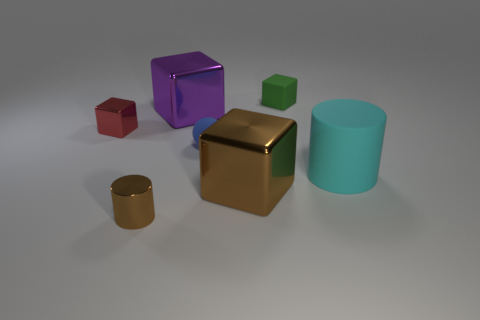There is a brown object that is right of the small rubber sphere; does it have the same shape as the red metallic thing?
Ensure brevity in your answer.  Yes. How many objects are either large red cylinders or purple shiny things?
Make the answer very short. 1. Does the tiny cube that is to the left of the tiny metal cylinder have the same material as the large purple thing?
Offer a very short reply. Yes. What size is the green cube?
Provide a succinct answer. Small. There is a large metal object that is the same color as the small cylinder; what is its shape?
Keep it short and to the point. Cube. How many blocks are either yellow shiny objects or red metal things?
Offer a terse response. 1. Is the number of big cyan rubber objects in front of the big cyan matte object the same as the number of green blocks behind the small green matte object?
Your response must be concise. Yes. There is a green rubber object that is the same shape as the big purple object; what is its size?
Your answer should be compact. Small. There is a shiny thing that is both behind the tiny cylinder and in front of the small red metallic cube; what size is it?
Your answer should be compact. Large. There is a cyan cylinder; are there any tiny objects behind it?
Your answer should be compact. Yes. 